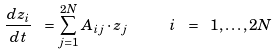<formula> <loc_0><loc_0><loc_500><loc_500>\frac { d z _ { i } } { d t } \ = \sum _ { j = 1 } ^ { 2 N } A _ { i j } \cdot z _ { j } \quad \ i \ = \ 1 , \dots , 2 N</formula> 